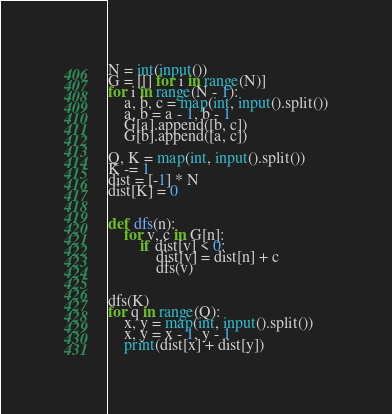Convert code to text. <code><loc_0><loc_0><loc_500><loc_500><_Python_>N = int(input())
G = [[] for i in range(N)]
for i in range(N - 1):
    a, b, c = map(int, input().split())
    a, b = a - 1, b - 1
    G[a].append([b, c])
    G[b].append([a, c])

Q, K = map(int, input().split())
K -= 1
dist = [-1] * N
dist[K] = 0


def dfs(n):
    for v, c in G[n]:
        if dist[v] < 0:
            dist[v] = dist[n] + c
            dfs(v)


dfs(K)
for q in range(Q):
    x, y = map(int, input().split())
    x, y = x - 1, y - 1
    print(dist[x] + dist[y])
</code> 